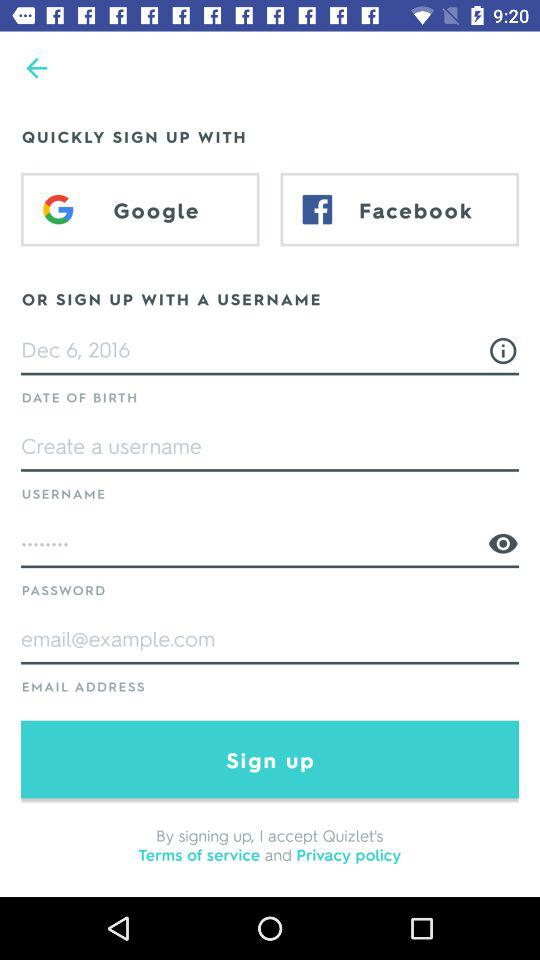What email address is given? The given email address is email@example.com. 